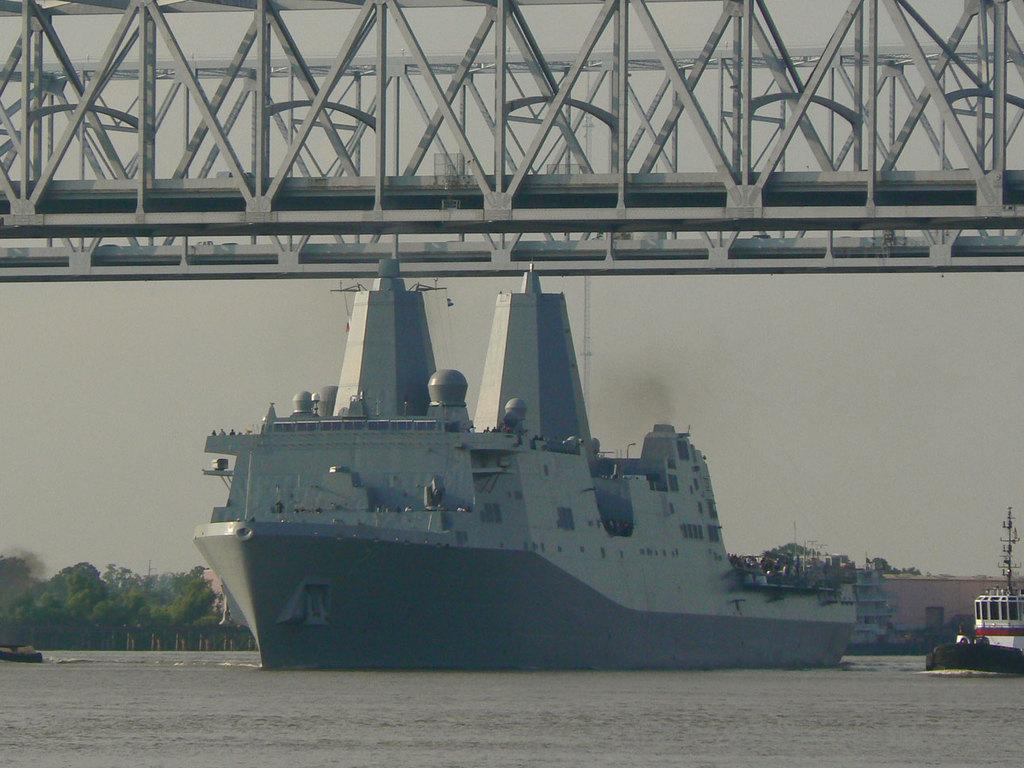What type of vehicle is present in the image? There is a ship in the image. Are there any other similar vehicles in the image? Yes, there are boats in the image. Where are the ship and boats located? The ship and boats are on the water in the image. What other structures can be seen in the image? There are buildings, trees, and a bridge in the image. What is visible in the background of the image? The sky is visible in the background of the image. What type of muscle is being exercised by the drum in the image? There is no drum present in the image, so it is not possible to determine which muscle might be exercised. 